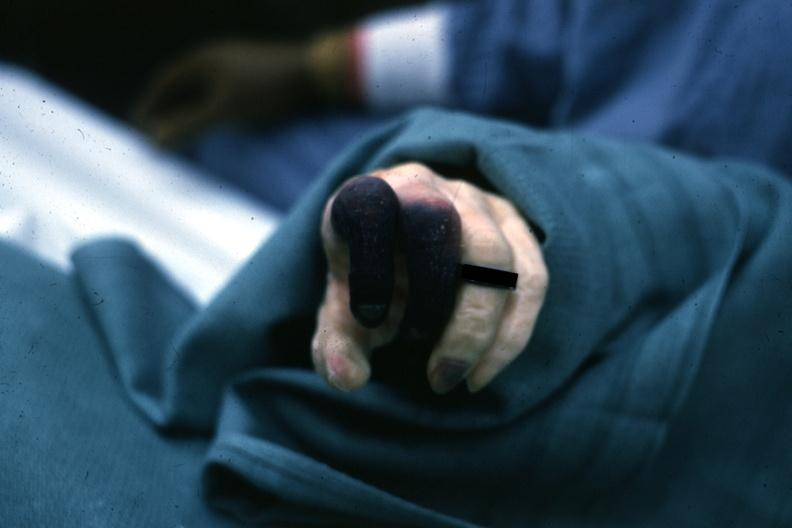does this image show excellent example gangrene first?
Answer the question using a single word or phrase. Yes 